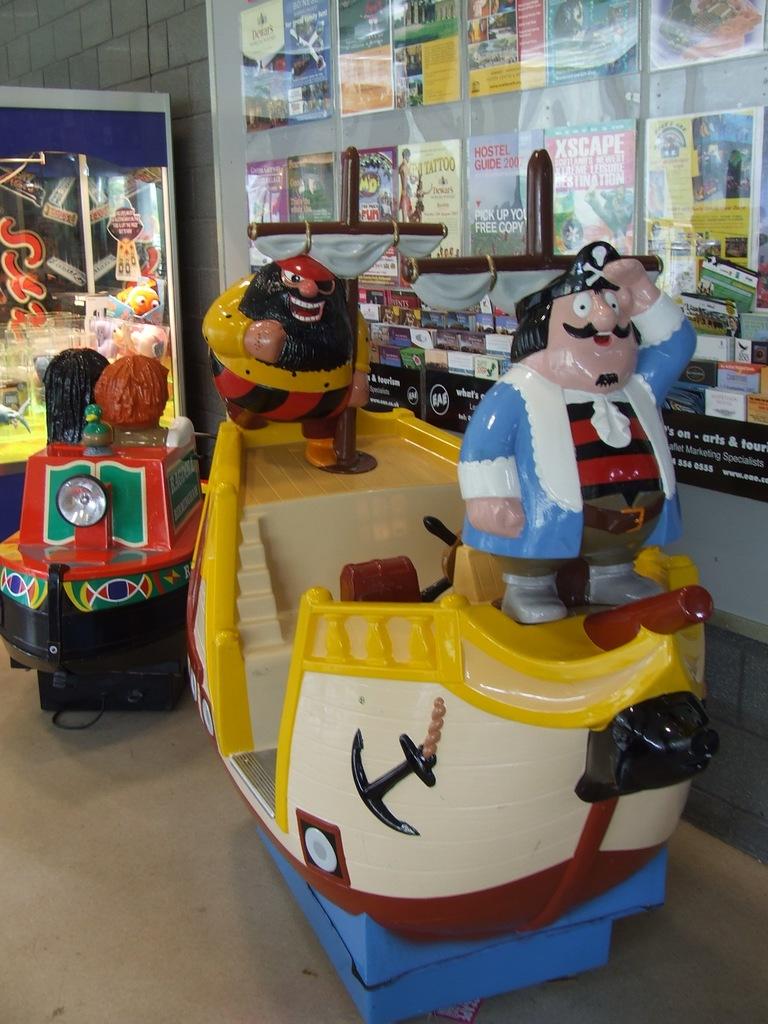What does one of the posters say, on the right?
Give a very brief answer. Xscape. What are the three letters in a circle, on the strip of black advertising?
Ensure brevity in your answer.  Eae. 